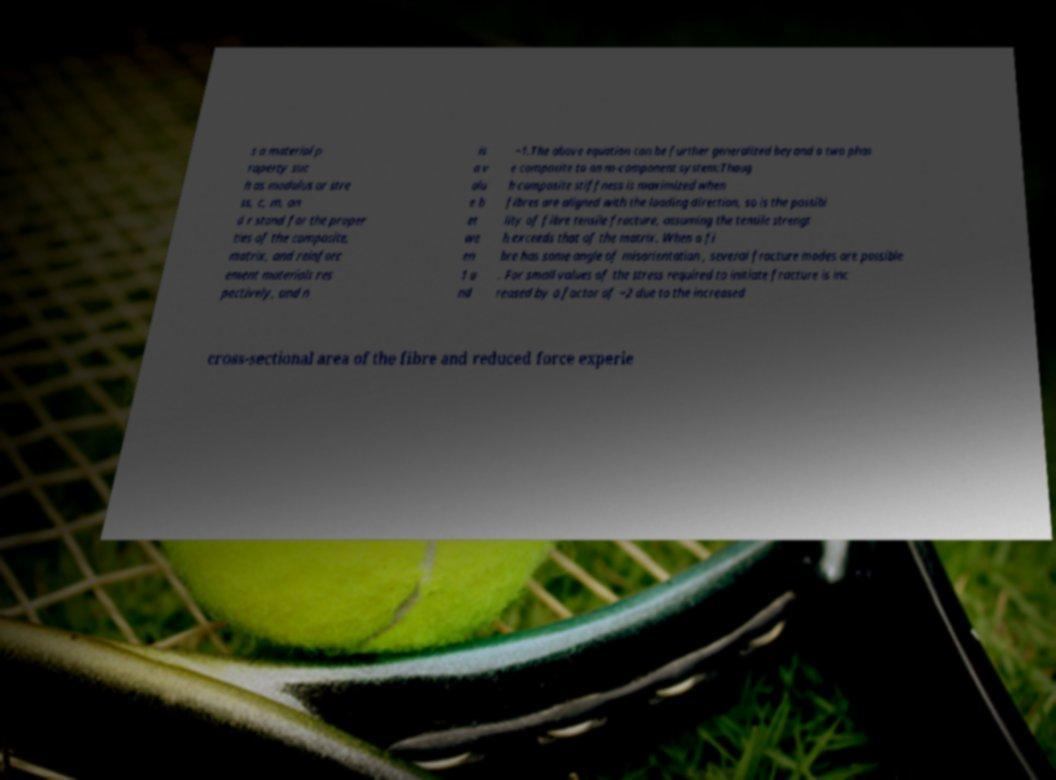Please read and relay the text visible in this image. What does it say? s a material p roperty suc h as modulus or stre ss, c, m, an d r stand for the proper ties of the composite, matrix, and reinforc ement materials res pectively, and n is a v alu e b et we en 1 a nd −1.The above equation can be further generalized beyond a two phas e composite to an m-component system:Thoug h composite stiffness is maximized when fibres are aligned with the loading direction, so is the possibi lity of fibre tensile fracture, assuming the tensile strengt h exceeds that of the matrix. When a fi bre has some angle of misorientation , several fracture modes are possible . For small values of the stress required to initiate fracture is inc reased by a factor of −2 due to the increased cross-sectional area of the fibre and reduced force experie 